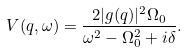Convert formula to latex. <formula><loc_0><loc_0><loc_500><loc_500>V ( q , \omega ) = \frac { 2 | g ( q ) | ^ { 2 } \Omega _ { 0 } } { \omega ^ { 2 } - \Omega ^ { 2 } _ { 0 } + i \delta } .</formula> 